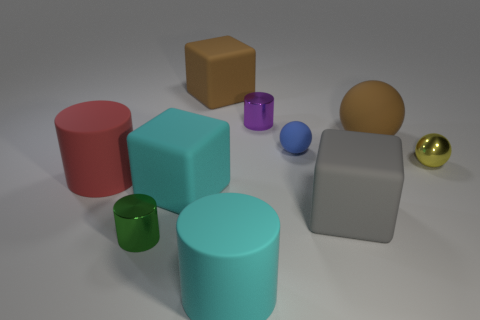Subtract all brown blocks. Subtract all cyan balls. How many blocks are left? 2 Subtract all blocks. How many objects are left? 7 Add 8 brown rubber balls. How many brown rubber balls exist? 9 Subtract 0 purple cubes. How many objects are left? 10 Subtract all purple cylinders. Subtract all big cyan objects. How many objects are left? 7 Add 5 tiny things. How many tiny things are left? 9 